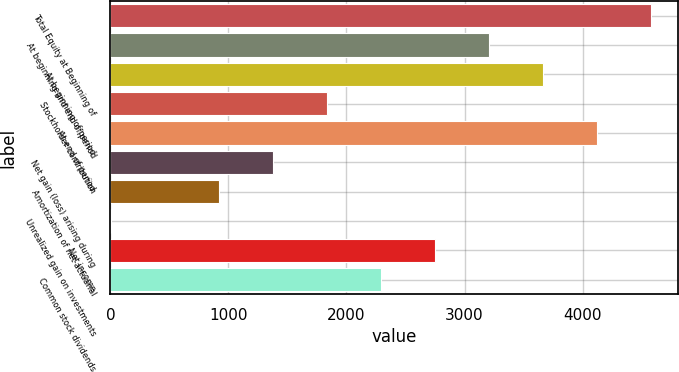Convert chart. <chart><loc_0><loc_0><loc_500><loc_500><bar_chart><fcel>Total Equity at Beginning of<fcel>At beginning and end of period<fcel>At beginning of period<fcel>Stockholder contribution<fcel>At end of period<fcel>Net gain (loss) arising during<fcel>Amortization of net actuarial<fcel>Unrealized gain on investments<fcel>Net income<fcel>Common stock dividends<nl><fcel>4582<fcel>3207.7<fcel>3665.8<fcel>1833.4<fcel>4123.9<fcel>1375.3<fcel>917.2<fcel>1<fcel>2749.6<fcel>2291.5<nl></chart> 